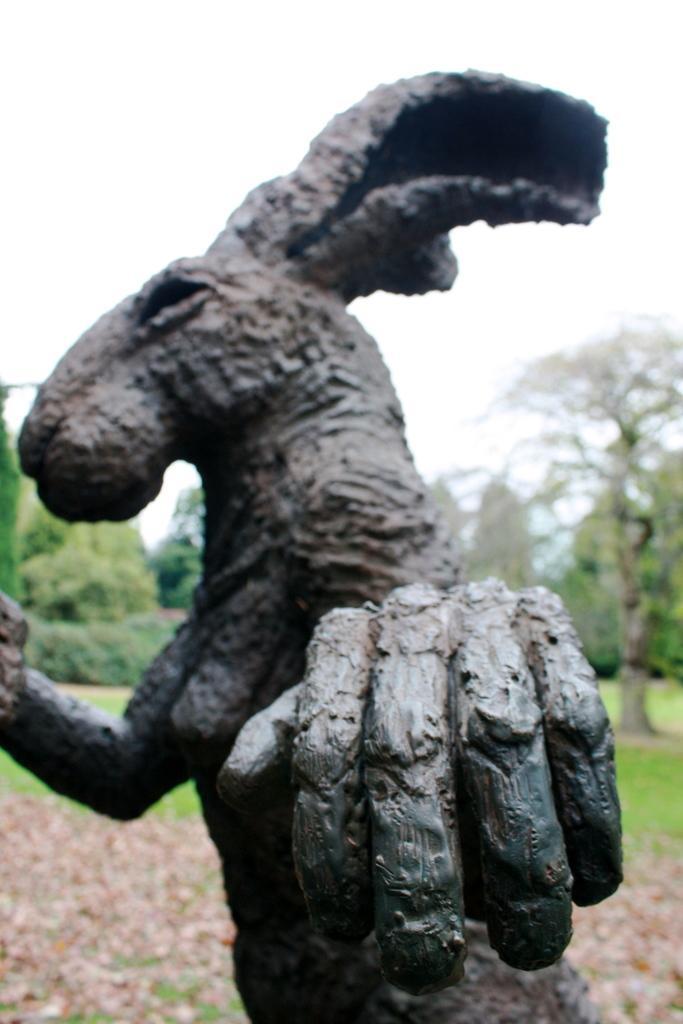Could you give a brief overview of what you see in this image? As we can see in the image in the front there is an animal statue. In the background there are trees. At the top there is sky. 